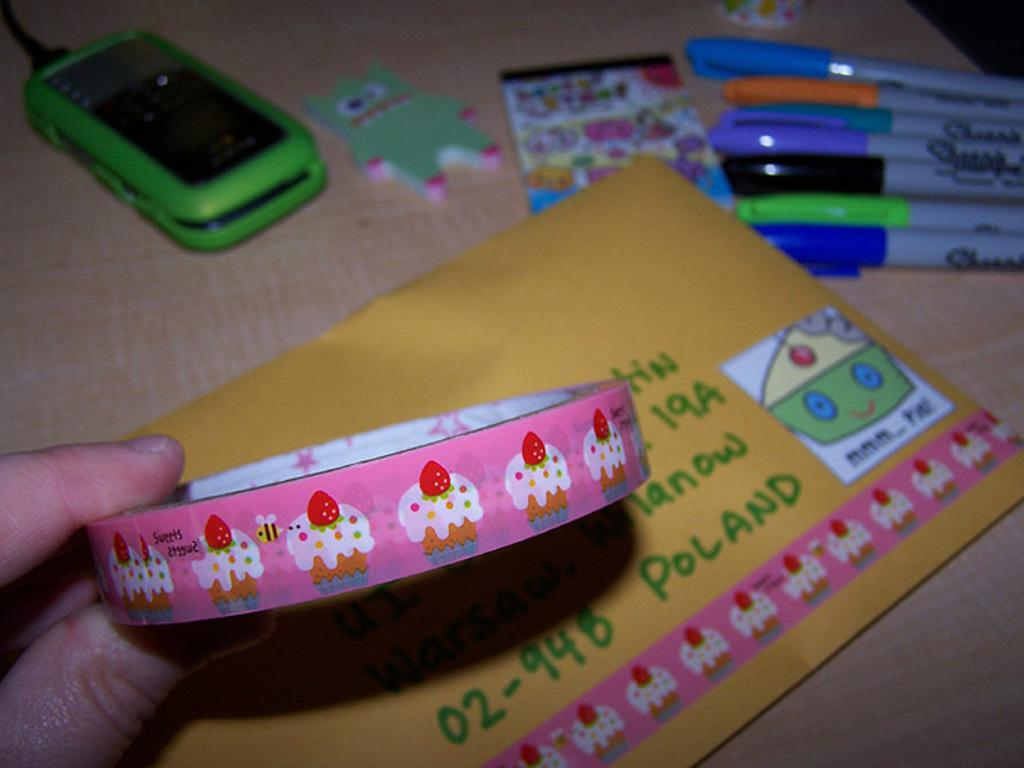<image>
Present a compact description of the photo's key features. A package being mailed to someone in Poland. 